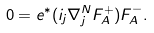Convert formula to latex. <formula><loc_0><loc_0><loc_500><loc_500>0 = e ^ { * } ( i _ { j } \nabla _ { j } ^ { N } F _ { A } ^ { + } ) F _ { A } ^ { - } .</formula> 